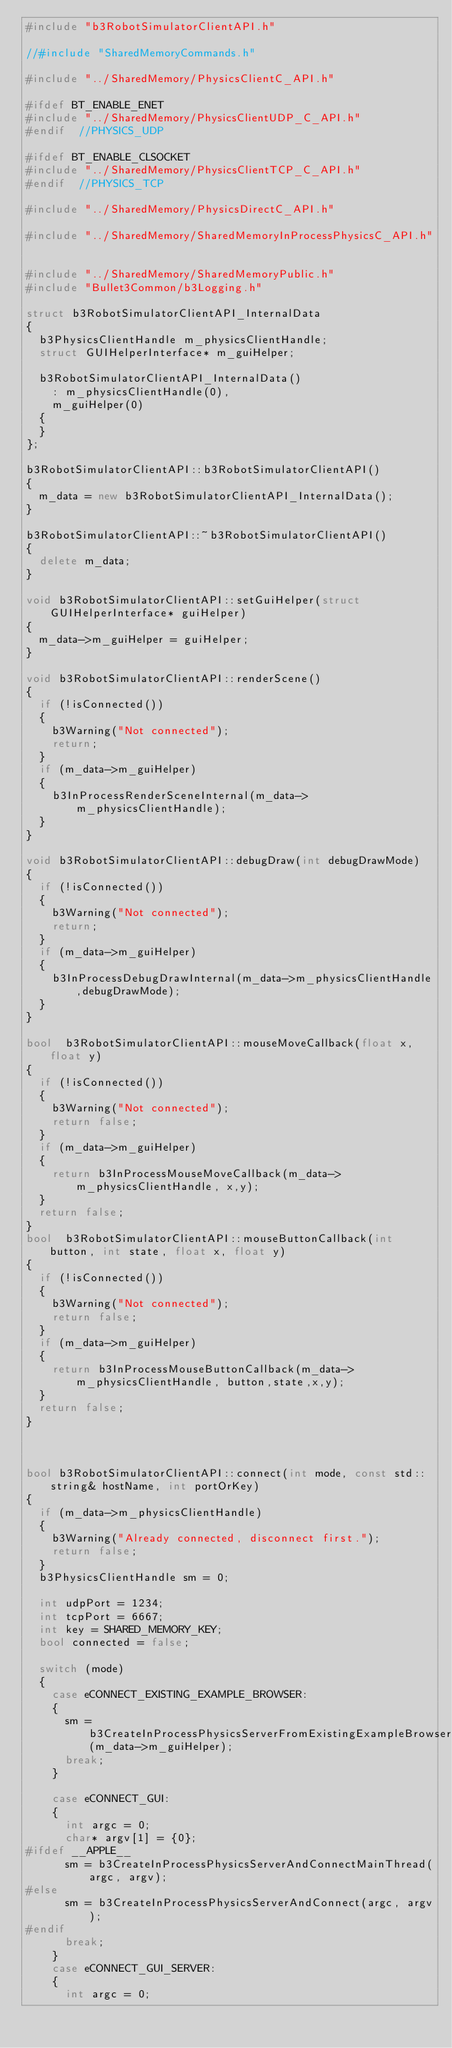<code> <loc_0><loc_0><loc_500><loc_500><_C++_>#include "b3RobotSimulatorClientAPI.h"

//#include "SharedMemoryCommands.h"

#include "../SharedMemory/PhysicsClientC_API.h"

#ifdef BT_ENABLE_ENET
#include "../SharedMemory/PhysicsClientUDP_C_API.h"
#endif  //PHYSICS_UDP

#ifdef BT_ENABLE_CLSOCKET
#include "../SharedMemory/PhysicsClientTCP_C_API.h"
#endif  //PHYSICS_TCP

#include "../SharedMemory/PhysicsDirectC_API.h"

#include "../SharedMemory/SharedMemoryInProcessPhysicsC_API.h"


#include "../SharedMemory/SharedMemoryPublic.h"
#include "Bullet3Common/b3Logging.h"

struct b3RobotSimulatorClientAPI_InternalData
{
	b3PhysicsClientHandle m_physicsClientHandle;
	struct GUIHelperInterface* m_guiHelper;

	b3RobotSimulatorClientAPI_InternalData()
		: m_physicsClientHandle(0),
		m_guiHelper(0)
	{
	}
};

b3RobotSimulatorClientAPI::b3RobotSimulatorClientAPI()
{
	m_data = new b3RobotSimulatorClientAPI_InternalData();
}

b3RobotSimulatorClientAPI::~b3RobotSimulatorClientAPI()
{
	delete m_data;
}

void b3RobotSimulatorClientAPI::setGuiHelper(struct GUIHelperInterface* guiHelper)
{
	m_data->m_guiHelper = guiHelper;
}

void b3RobotSimulatorClientAPI::renderScene()
{
	if (!isConnected())
	{
		b3Warning("Not connected");
		return;
	}
	if (m_data->m_guiHelper)
	{
		b3InProcessRenderSceneInternal(m_data->m_physicsClientHandle);
	}
}

void b3RobotSimulatorClientAPI::debugDraw(int debugDrawMode)
{
	if (!isConnected())
	{
		b3Warning("Not connected");
		return;
	}
	if (m_data->m_guiHelper)
	{
		b3InProcessDebugDrawInternal(m_data->m_physicsClientHandle,debugDrawMode);
	}
}

bool	b3RobotSimulatorClientAPI::mouseMoveCallback(float x,float y)
{
	if (!isConnected())
	{
		b3Warning("Not connected");
		return false;
	}
	if (m_data->m_guiHelper)
	{
		return b3InProcessMouseMoveCallback(m_data->m_physicsClientHandle, x,y);
	}
	return false;
}
bool	b3RobotSimulatorClientAPI::mouseButtonCallback(int button, int state, float x, float y)
{
	if (!isConnected())
	{
		b3Warning("Not connected");
		return false;
	}
	if (m_data->m_guiHelper)
	{
		return b3InProcessMouseButtonCallback(m_data->m_physicsClientHandle, button,state,x,y);
	}
	return false;
}



bool b3RobotSimulatorClientAPI::connect(int mode, const std::string& hostName, int portOrKey)
{
	if (m_data->m_physicsClientHandle)
	{
		b3Warning("Already connected, disconnect first.");
		return false;
	}
	b3PhysicsClientHandle sm = 0;

	int udpPort = 1234;
	int tcpPort = 6667;
	int key = SHARED_MEMORY_KEY;
	bool connected = false;

	switch (mode)
	{
		case eCONNECT_EXISTING_EXAMPLE_BROWSER:
		{
			sm = b3CreateInProcessPhysicsServerFromExistingExampleBrowserAndConnect(m_data->m_guiHelper);
			break;
		}

		case eCONNECT_GUI:
		{
			int argc = 0;
			char* argv[1] = {0};
#ifdef __APPLE__
			sm = b3CreateInProcessPhysicsServerAndConnectMainThread(argc, argv);
#else
			sm = b3CreateInProcessPhysicsServerAndConnect(argc, argv);
#endif
			break;
		}
		case eCONNECT_GUI_SERVER:
		{
			int argc = 0;</code> 